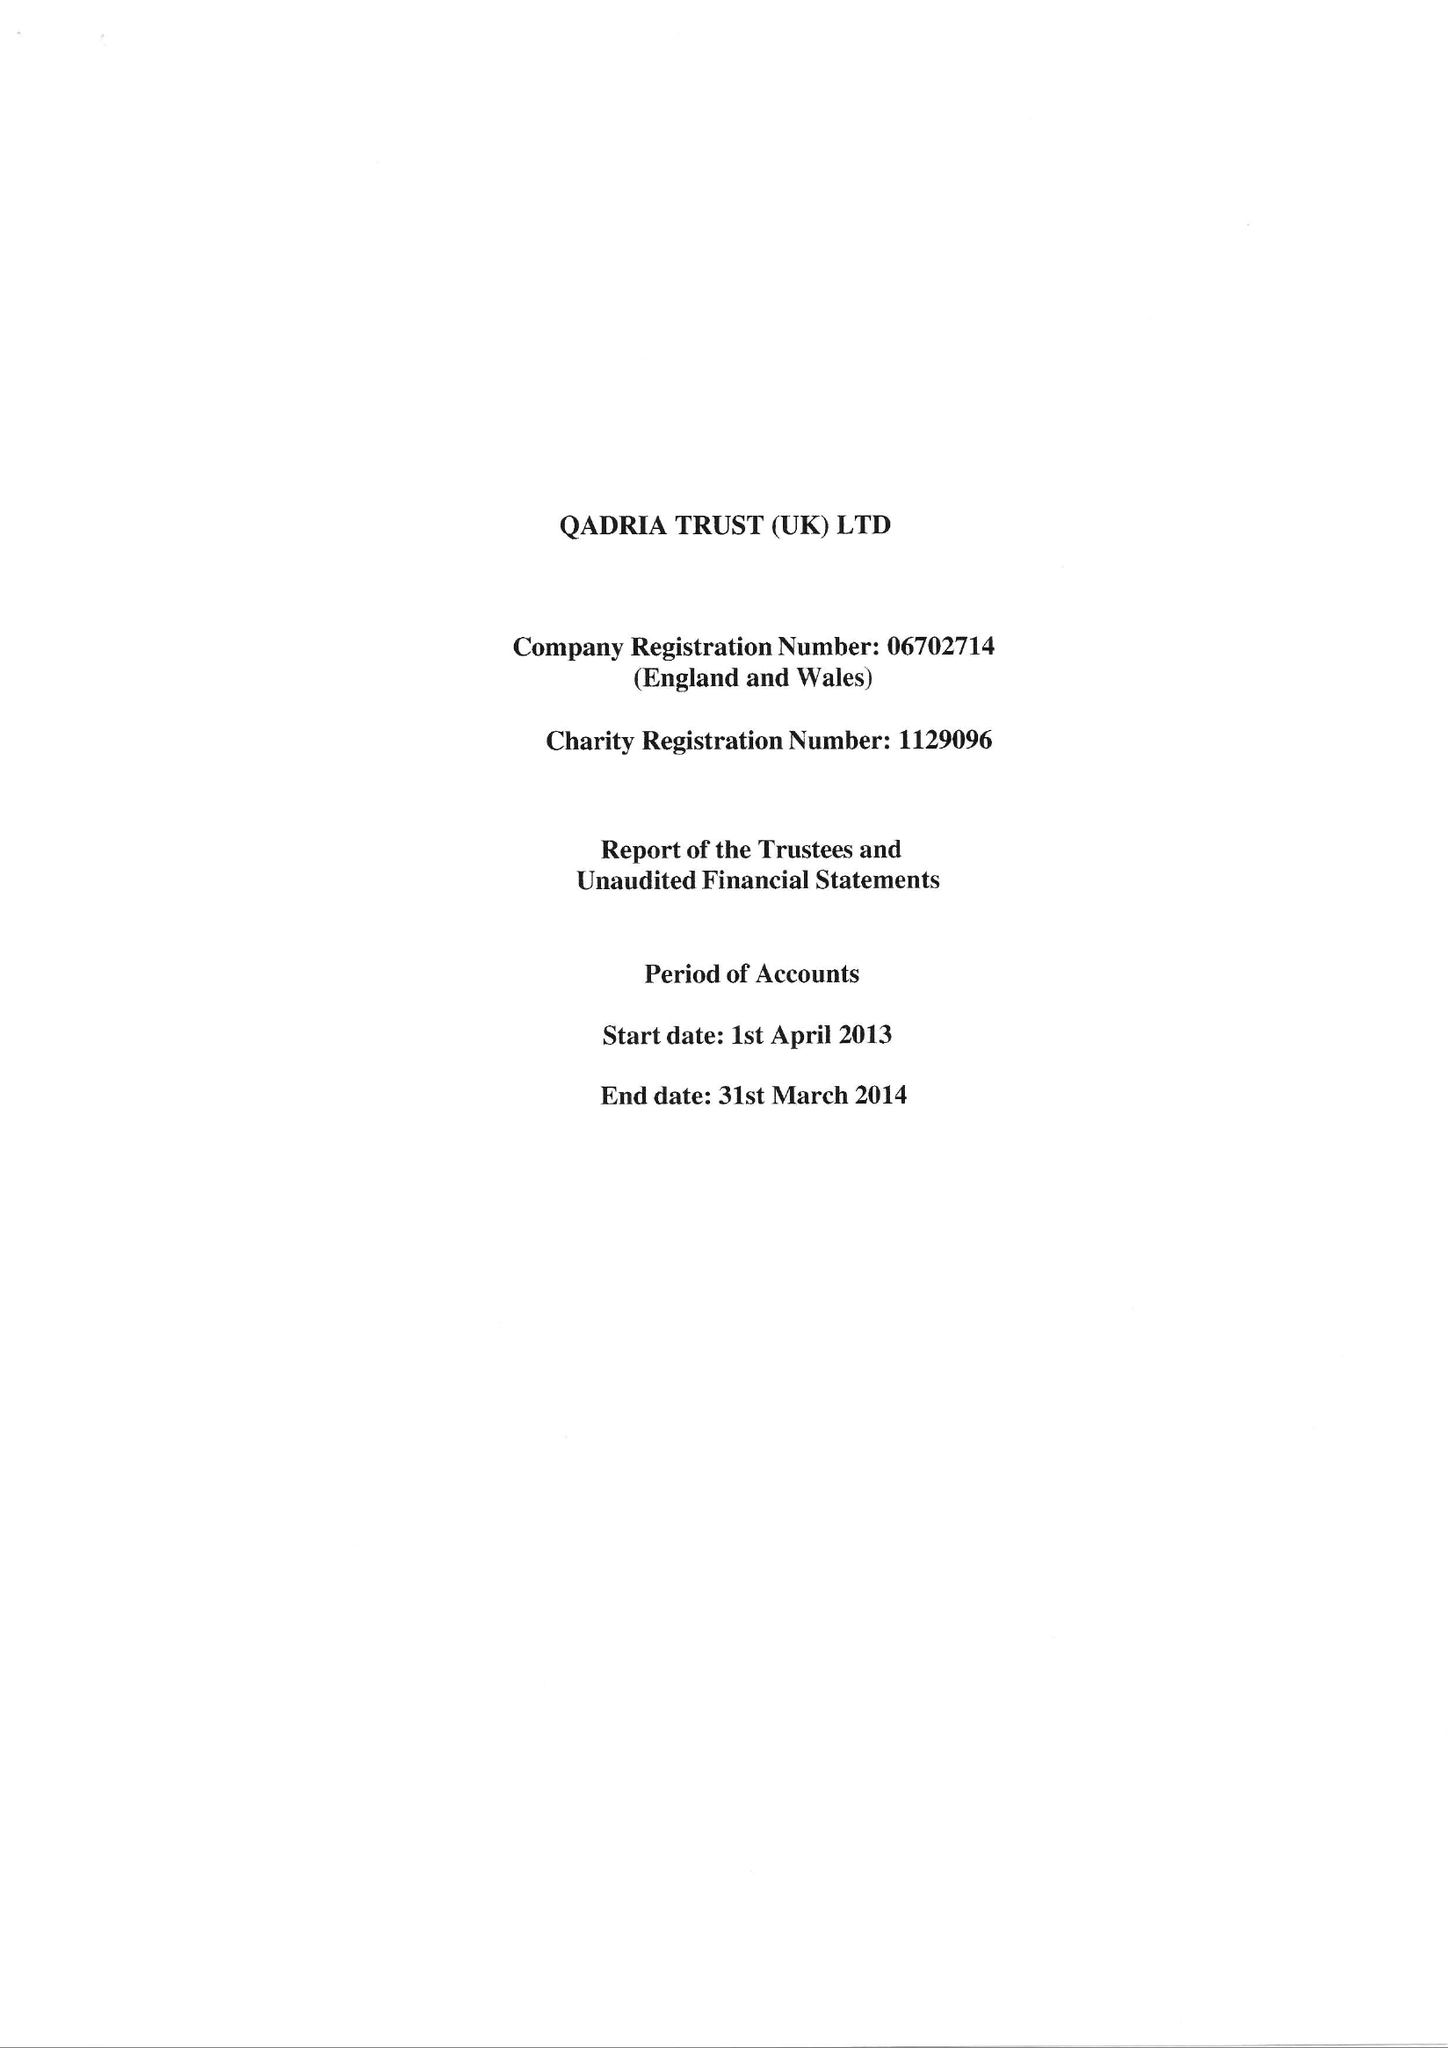What is the value for the address__street_line?
Answer the question using a single word or phrase. 26 ALFRED STREET 